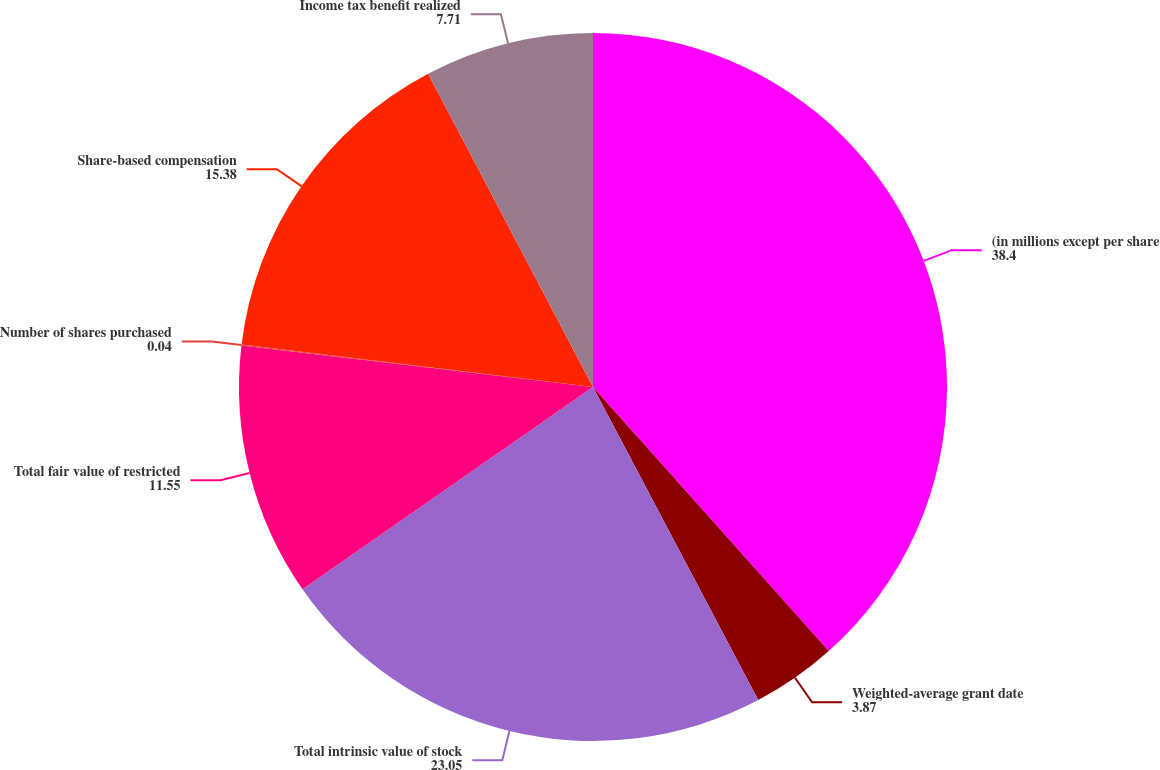Convert chart. <chart><loc_0><loc_0><loc_500><loc_500><pie_chart><fcel>(in millions except per share<fcel>Weighted-average grant date<fcel>Total intrinsic value of stock<fcel>Total fair value of restricted<fcel>Number of shares purchased<fcel>Share-based compensation<fcel>Income tax benefit realized<nl><fcel>38.4%<fcel>3.87%<fcel>23.05%<fcel>11.55%<fcel>0.04%<fcel>15.38%<fcel>7.71%<nl></chart> 